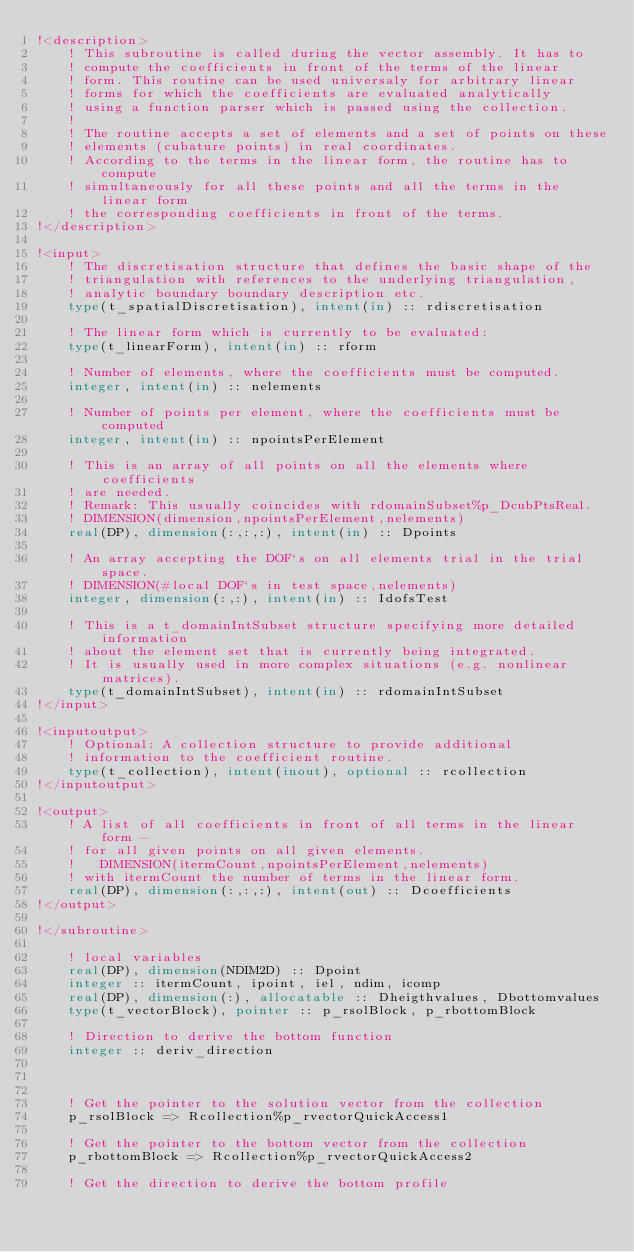Convert code to text. <code><loc_0><loc_0><loc_500><loc_500><_FORTRAN_>!<description>
    ! This subroutine is called during the vector assembly. It has to
    ! compute the coefficients in front of the terms of the linear
    ! form. This routine can be used universaly for arbitrary linear
    ! forms for which the coefficients are evaluated analytically
    ! using a function parser which is passed using the collection.
    !
    ! The routine accepts a set of elements and a set of points on these
    ! elements (cubature points) in real coordinates.
    ! According to the terms in the linear form, the routine has to compute
    ! simultaneously for all these points and all the terms in the linear form
    ! the corresponding coefficients in front of the terms.
!</description>
    
!<input>
    ! The discretisation structure that defines the basic shape of the
    ! triangulation with references to the underlying triangulation,
    ! analytic boundary boundary description etc.
    type(t_spatialDiscretisation), intent(in) :: rdiscretisation
    
    ! The linear form which is currently to be evaluated:
    type(t_linearForm), intent(in) :: rform
    
    ! Number of elements, where the coefficients must be computed.
    integer, intent(in) :: nelements
    
    ! Number of points per element, where the coefficients must be computed
    integer, intent(in) :: npointsPerElement
    
    ! This is an array of all points on all the elements where coefficients
    ! are needed.
    ! Remark: This usually coincides with rdomainSubset%p_DcubPtsReal.
    ! DIMENSION(dimension,npointsPerElement,nelements)
    real(DP), dimension(:,:,:), intent(in) :: Dpoints

    ! An array accepting the DOF`s on all elements trial in the trial space.
    ! DIMENSION(#local DOF`s in test space,nelements)
    integer, dimension(:,:), intent(in) :: IdofsTest

    ! This is a t_domainIntSubset structure specifying more detailed information
    ! about the element set that is currently being integrated.
    ! It is usually used in more complex situations (e.g. nonlinear matrices).
    type(t_domainIntSubset), intent(in) :: rdomainIntSubset
!</input>

!<inputoutput>
    ! Optional: A collection structure to provide additional
    ! information to the coefficient routine.
    type(t_collection), intent(inout), optional :: rcollection
!</inputoutput>
  
!<output>
    ! A list of all coefficients in front of all terms in the linear form -
    ! for all given points on all given elements.
    !   DIMENSION(itermCount,npointsPerElement,nelements)
    ! with itermCount the number of terms in the linear form.
    real(DP), dimension(:,:,:), intent(out) :: Dcoefficients
!</output>
    
!</subroutine>

    ! local variables
    real(DP), dimension(NDIM2D) :: Dpoint
    integer :: itermCount, ipoint, iel, ndim, icomp
    real(DP), dimension(:), allocatable :: Dheigthvalues, Dbottomvalues
    type(t_vectorBlock), pointer :: p_rsolBlock, p_rbottomBlock

    ! Direction to derive the bottom function
    integer :: deriv_direction



    ! Get the pointer to the solution vector from the collection
    p_rsolBlock => Rcollection%p_rvectorQuickAccess1
    
    ! Get the pointer to the bottom vector from the collection
    p_rbottomBlock => Rcollection%p_rvectorQuickAccess2
    
    ! Get the direction to derive the bottom profile</code> 